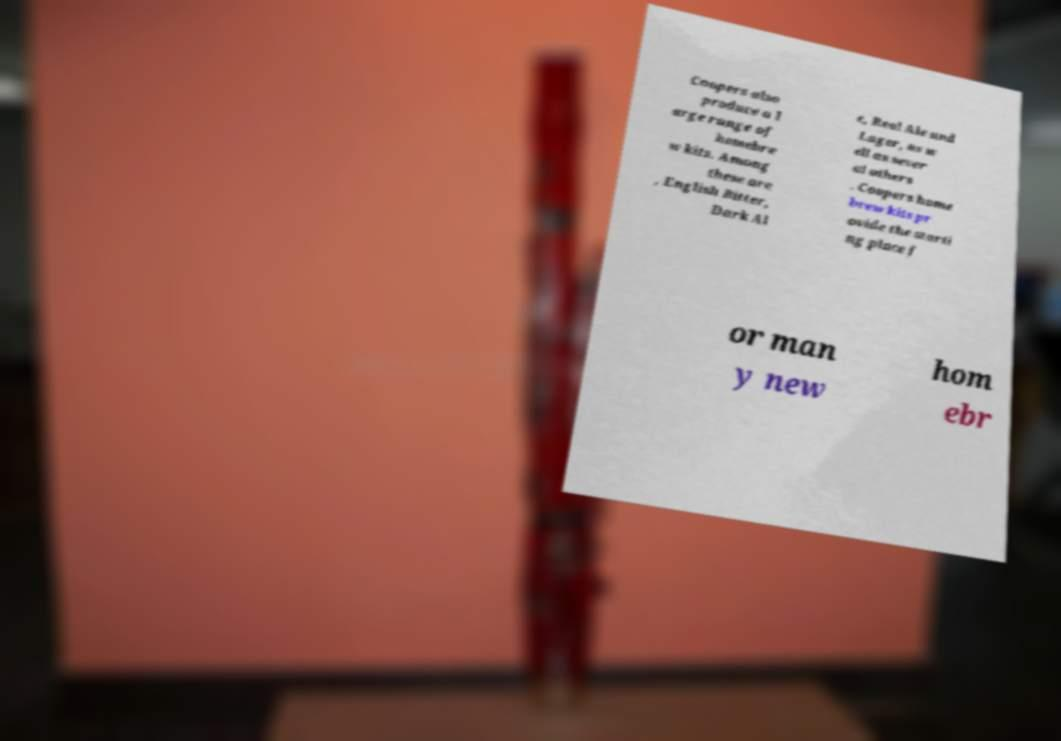Please read and relay the text visible in this image. What does it say? Coopers also produce a l arge range of homebre w kits. Among these are , English Bitter, Dark Al e, Real Ale and Lager, as w ell as sever al others . Coopers home brew kits pr ovide the starti ng place f or man y new hom ebr 